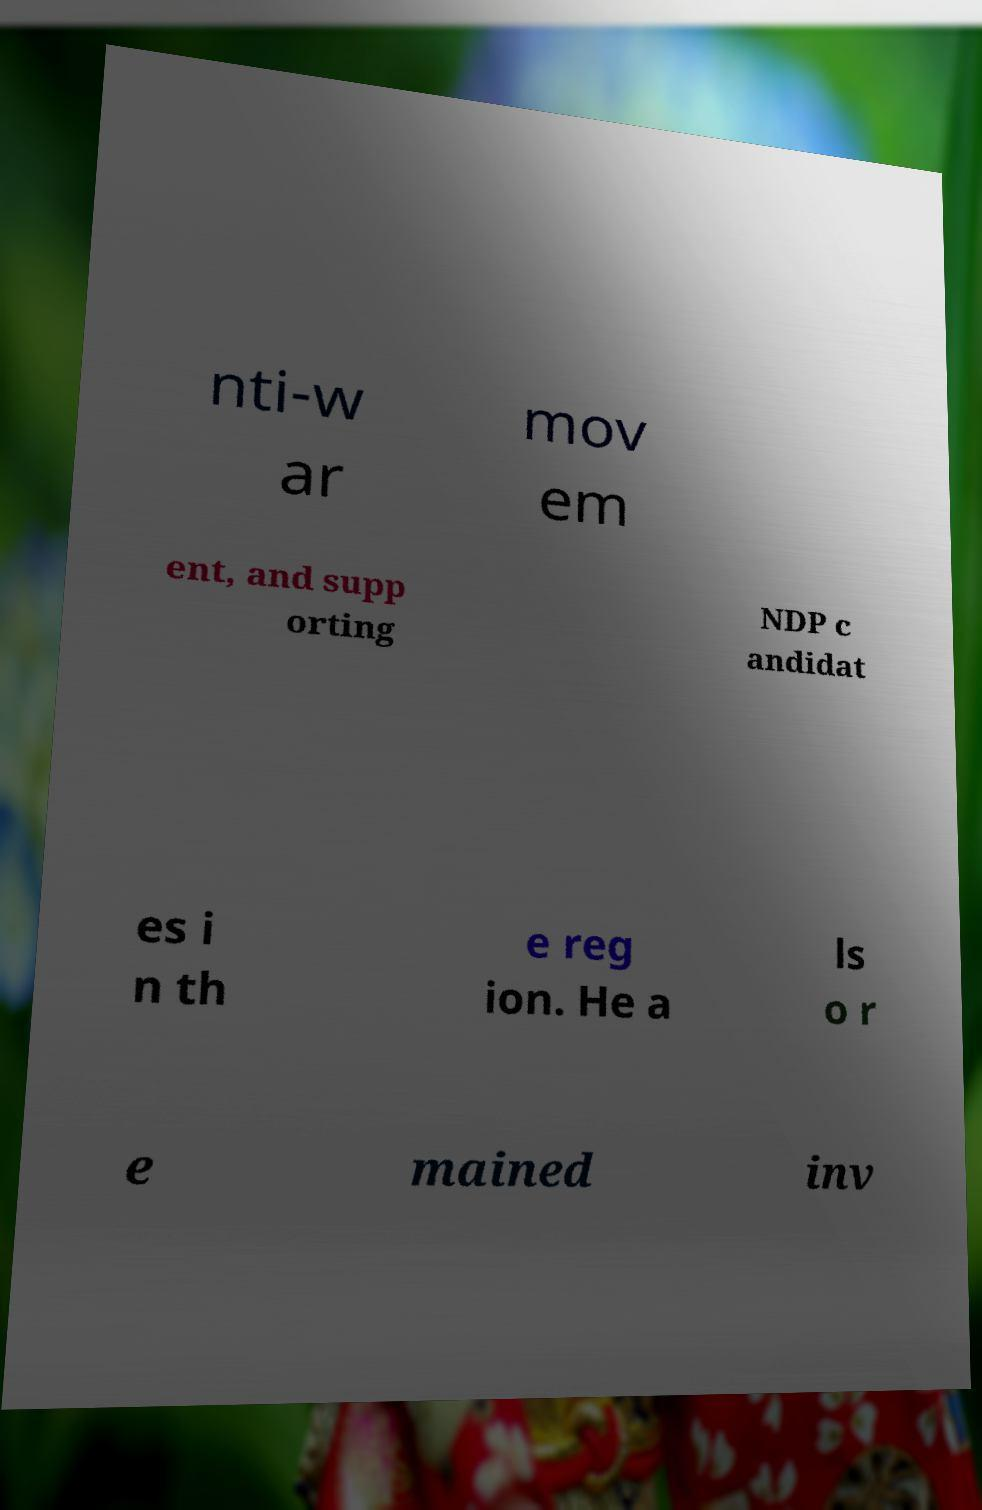Please read and relay the text visible in this image. What does it say? nti-w ar mov em ent, and supp orting NDP c andidat es i n th e reg ion. He a ls o r e mained inv 